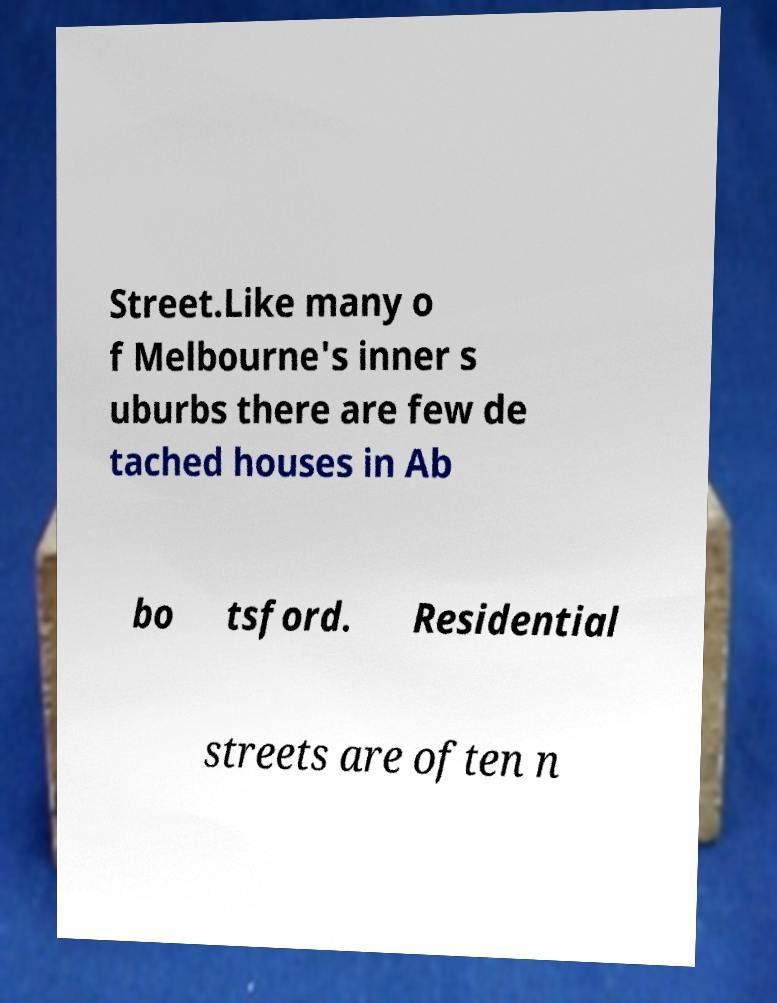Please identify and transcribe the text found in this image. Street.Like many o f Melbourne's inner s uburbs there are few de tached houses in Ab bo tsford. Residential streets are often n 